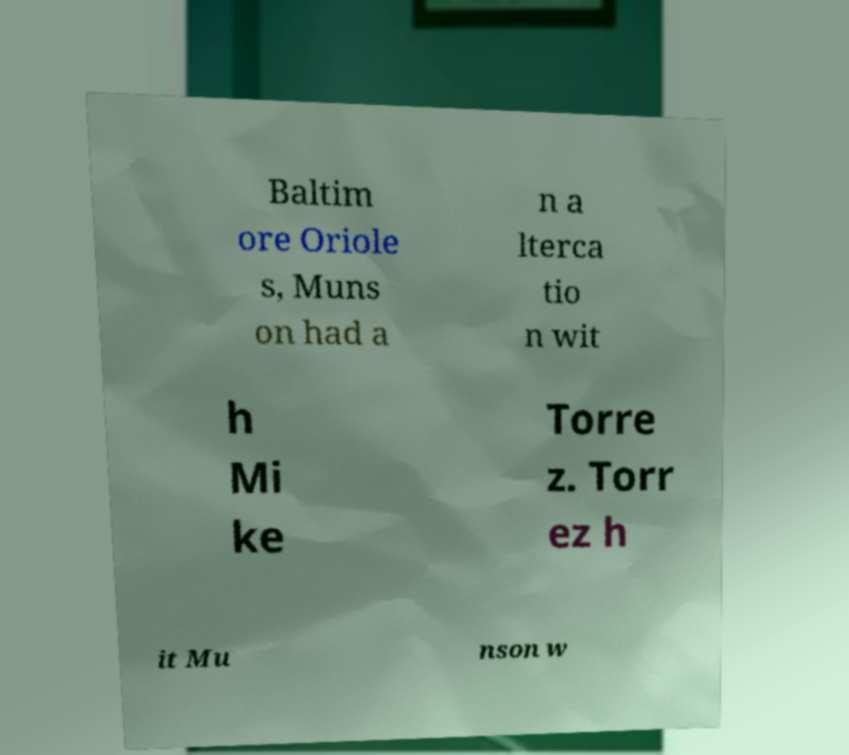Could you assist in decoding the text presented in this image and type it out clearly? Baltim ore Oriole s, Muns on had a n a lterca tio n wit h Mi ke Torre z. Torr ez h it Mu nson w 